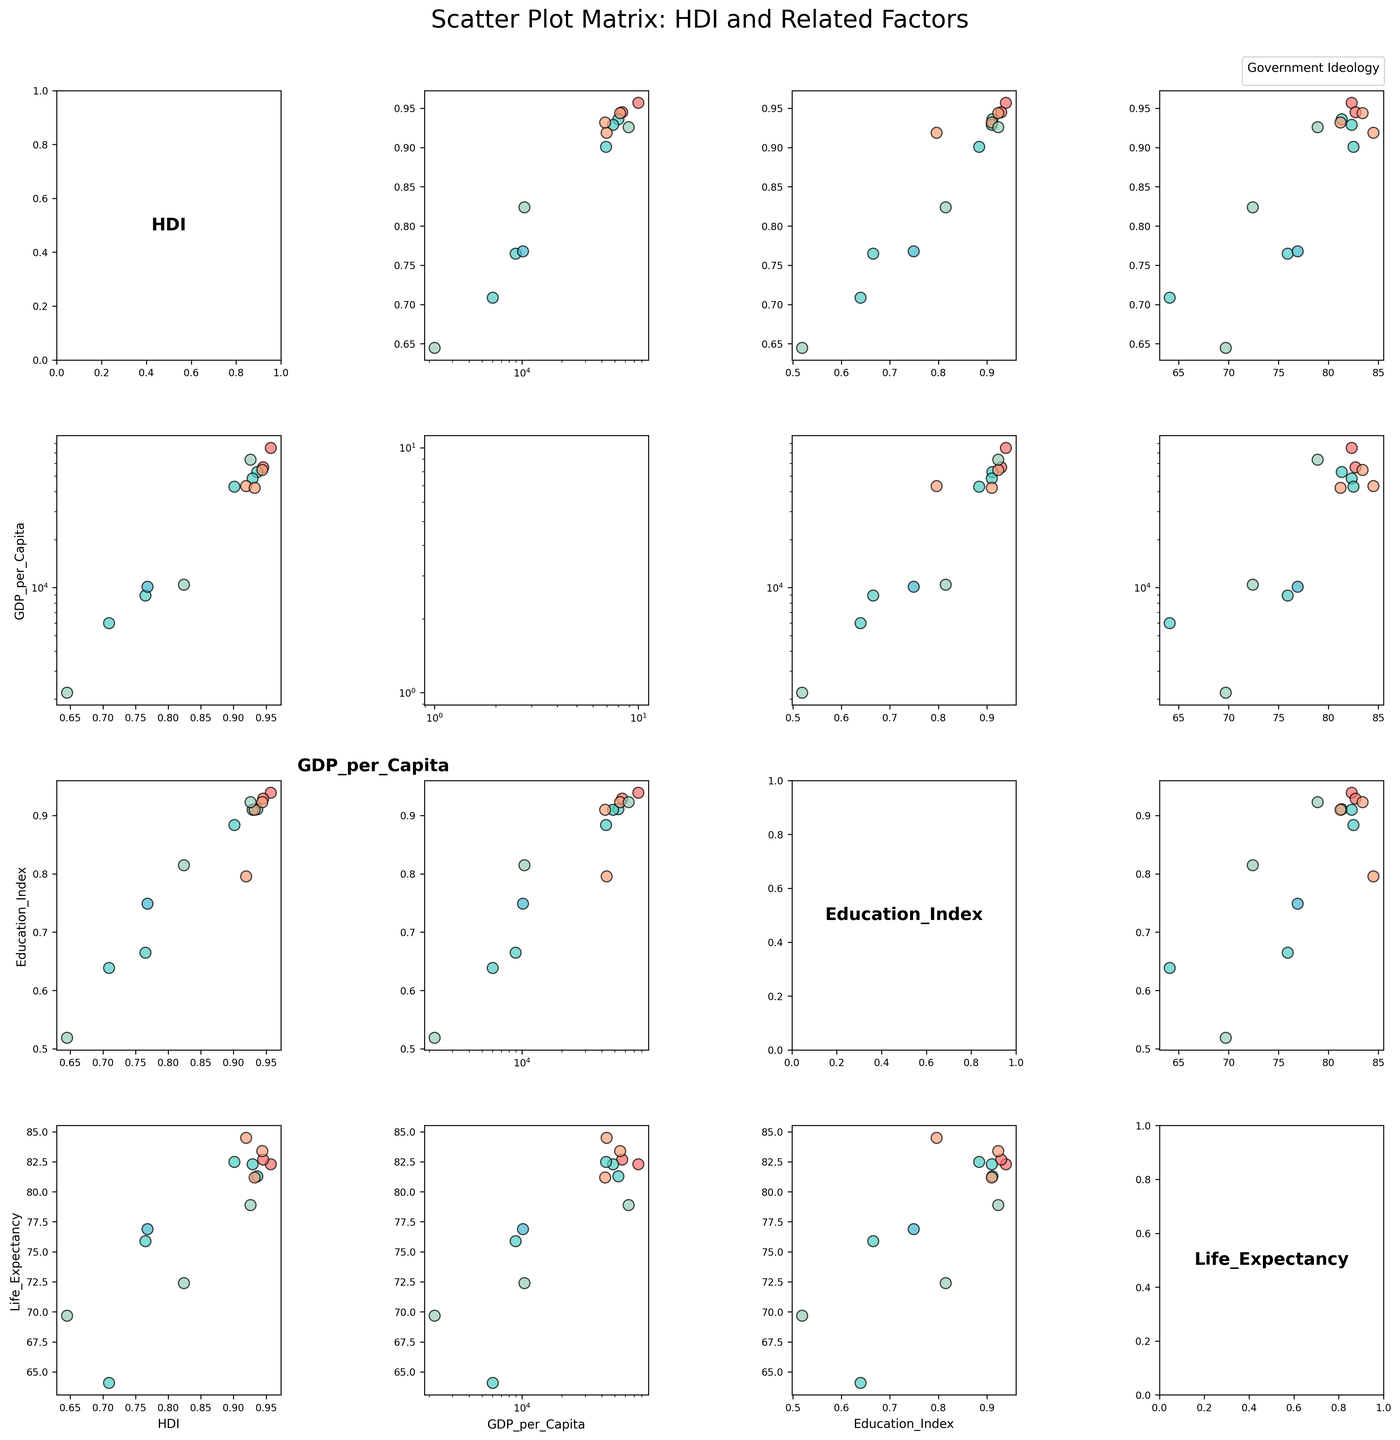What is the title of the figure? The title is usually found at the top of the figure. Here, it clearly states "Scatter Plot Matrix: HDI and Related Factors."
Answer: Scatter Plot Matrix: HDI and Related Factors Which variable is plotted on the diagonal cells? In a scatter plot matrix, the diagonal cells typically display the variable name of the row and column it intersects. Here, variables like HDI, GDP_per_Capita, Education_Index, and Life_Expectancy are shown on the diagonals.
Answer: HDI, GDP_per_Capita, Education_Index, Life_Expectancy What color represents the "Left" government ideology? The scatter plot uses different colors to distinguish government ideologies. By observing the legend, we can see that the color used for the "Left" ideology is red.
Answer: Red Which country has the highest HDI? By looking at the HDI row, the scatter plot with the highest y-value will represent the country with the highest HDI. Norway is at the highest point in the HDI axis.
Answer: Norway Is there a correlation between GDP per Capita and Life Expectancy? To determine this, observe the scatter plot in the cell where GDP per Capita is on the x-axis and Life Expectancy is on the y-axis. The data points should show a trend, either increasing or decreasing. Here, the points exhibit a trend indicating that as GDP per Capita increases, so does Life Expectancy.
Answer: Yes, positive correlation Which government ideology spans the widest range of GDP per Capita? To find this, look at the scatter plots involving GDP per Capita on the x-axis. The variability for ‘Right’ ideologies seems wider, as their data points span from low to high GDP per Capita.
Answer: Right Among 'Center-Left' ideologies, which country has the lowest Education Index? Focus on the scatter plots involving countries with Center-Left ideologies and check for the minimum y-value in the Education Index column. Brazil has the lowest Education Index among Center-Left ideologies.
Answer: Brazil How does Japan’s Life Expectancy compare to that of Australia? Locate Japan and Australia on the Life Expectancy row and compare their positions. Japan's data point is higher on the y-axis, indicating a higher Life Expectancy.
Answer: Japan Which variable (GDP per Capita or Education Index) shows a stronger correlation with HDI? Compare the scatter plots of HDI vs. GDP per Capita with that of HDI vs. Education Index. The tighter the cluster of points along a trend line, the stronger the correlation. The HDI vs. Education Index plot shows a tighter cluster, indicating a stronger correlation.
Answer: Education Index What general trend can be observed between HDI and Government Ideology? Look at the scatter plots where HDI is plotted against other factors. Notice how different ideologies cluster around certain HDI values. Left and Center-Left countries generally feature higher HDI values.
Answer: Higher HDI for Left and Center-Left ideologies 